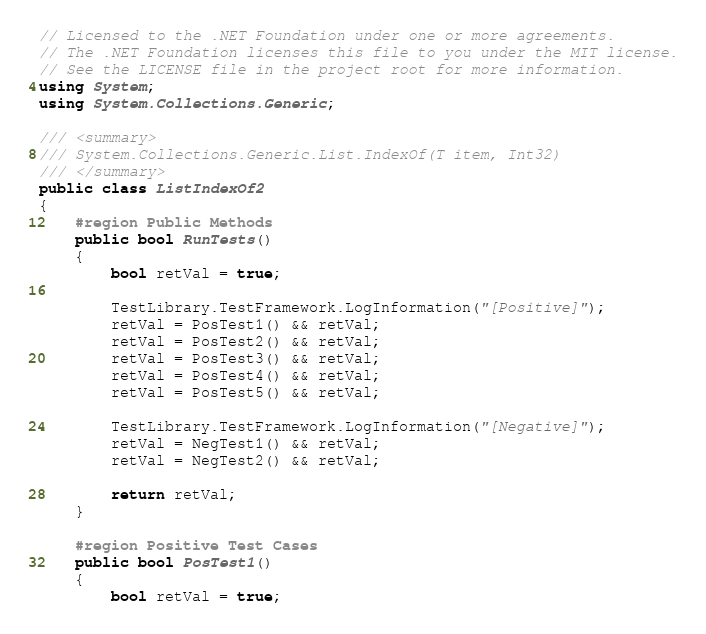Convert code to text. <code><loc_0><loc_0><loc_500><loc_500><_C#_>// Licensed to the .NET Foundation under one or more agreements.
// The .NET Foundation licenses this file to you under the MIT license.
// See the LICENSE file in the project root for more information.
using System;
using System.Collections.Generic;

/// <summary>
/// System.Collections.Generic.List.IndexOf(T item, Int32)
/// </summary>
public class ListIndexOf2
{
    #region Public Methods
    public bool RunTests()
    {
        bool retVal = true;

        TestLibrary.TestFramework.LogInformation("[Positive]");
        retVal = PosTest1() && retVal;
        retVal = PosTest2() && retVal;
        retVal = PosTest3() && retVal;
        retVal = PosTest4() && retVal;
        retVal = PosTest5() && retVal;

        TestLibrary.TestFramework.LogInformation("[Negative]");
        retVal = NegTest1() && retVal;
        retVal = NegTest2() && retVal;

        return retVal;
    }

    #region Positive Test Cases
    public bool PosTest1()
    {
        bool retVal = true;
</code> 